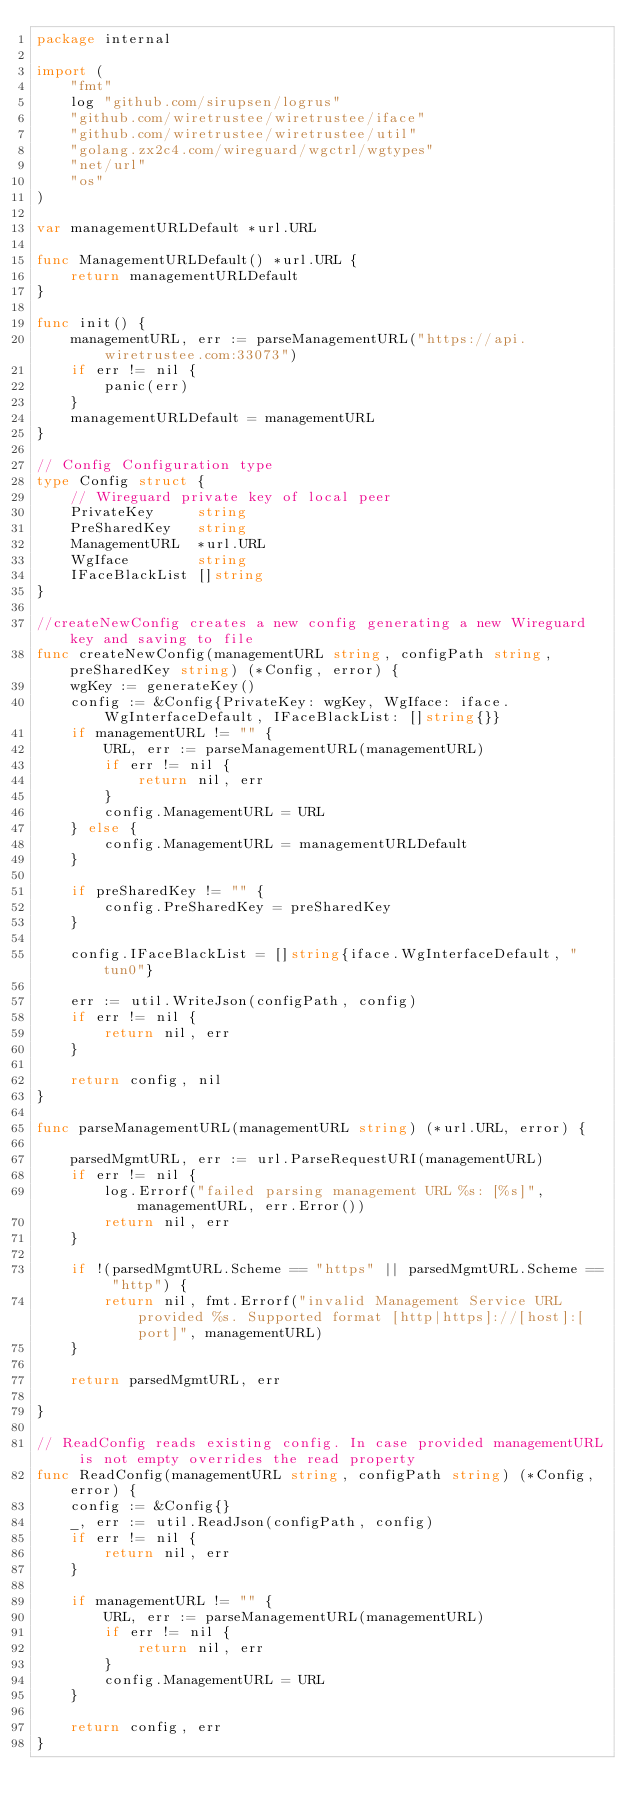<code> <loc_0><loc_0><loc_500><loc_500><_Go_>package internal

import (
	"fmt"
	log "github.com/sirupsen/logrus"
	"github.com/wiretrustee/wiretrustee/iface"
	"github.com/wiretrustee/wiretrustee/util"
	"golang.zx2c4.com/wireguard/wgctrl/wgtypes"
	"net/url"
	"os"
)

var managementURLDefault *url.URL

func ManagementURLDefault() *url.URL {
	return managementURLDefault
}

func init() {
	managementURL, err := parseManagementURL("https://api.wiretrustee.com:33073")
	if err != nil {
		panic(err)
	}
	managementURLDefault = managementURL
}

// Config Configuration type
type Config struct {
	// Wireguard private key of local peer
	PrivateKey     string
	PreSharedKey   string
	ManagementURL  *url.URL
	WgIface        string
	IFaceBlackList []string
}

//createNewConfig creates a new config generating a new Wireguard key and saving to file
func createNewConfig(managementURL string, configPath string, preSharedKey string) (*Config, error) {
	wgKey := generateKey()
	config := &Config{PrivateKey: wgKey, WgIface: iface.WgInterfaceDefault, IFaceBlackList: []string{}}
	if managementURL != "" {
		URL, err := parseManagementURL(managementURL)
		if err != nil {
			return nil, err
		}
		config.ManagementURL = URL
	} else {
		config.ManagementURL = managementURLDefault
	}

	if preSharedKey != "" {
		config.PreSharedKey = preSharedKey
	}

	config.IFaceBlackList = []string{iface.WgInterfaceDefault, "tun0"}

	err := util.WriteJson(configPath, config)
	if err != nil {
		return nil, err
	}

	return config, nil
}

func parseManagementURL(managementURL string) (*url.URL, error) {

	parsedMgmtURL, err := url.ParseRequestURI(managementURL)
	if err != nil {
		log.Errorf("failed parsing management URL %s: [%s]", managementURL, err.Error())
		return nil, err
	}

	if !(parsedMgmtURL.Scheme == "https" || parsedMgmtURL.Scheme == "http") {
		return nil, fmt.Errorf("invalid Management Service URL provided %s. Supported format [http|https]://[host]:[port]", managementURL)
	}

	return parsedMgmtURL, err

}

// ReadConfig reads existing config. In case provided managementURL is not empty overrides the read property
func ReadConfig(managementURL string, configPath string) (*Config, error) {
	config := &Config{}
	_, err := util.ReadJson(configPath, config)
	if err != nil {
		return nil, err
	}

	if managementURL != "" {
		URL, err := parseManagementURL(managementURL)
		if err != nil {
			return nil, err
		}
		config.ManagementURL = URL
	}

	return config, err
}
</code> 